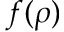Convert formula to latex. <formula><loc_0><loc_0><loc_500><loc_500>f ( \rho )</formula> 